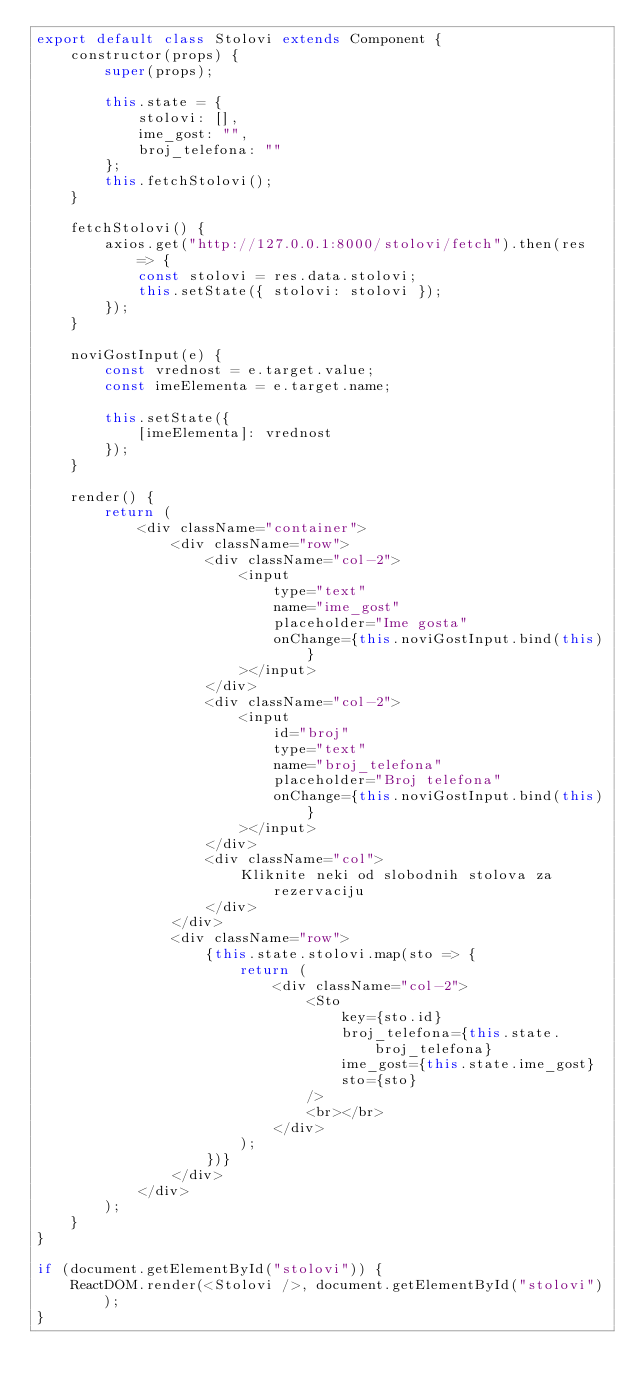Convert code to text. <code><loc_0><loc_0><loc_500><loc_500><_JavaScript_>export default class Stolovi extends Component {
    constructor(props) {
        super(props);

        this.state = {
            stolovi: [],
            ime_gost: "",
            broj_telefona: ""
        };
        this.fetchStolovi();
    }

    fetchStolovi() {
        axios.get("http://127.0.0.1:8000/stolovi/fetch").then(res => {
            const stolovi = res.data.stolovi;
            this.setState({ stolovi: stolovi });
        });
    }

    noviGostInput(e) {
        const vrednost = e.target.value;
        const imeElementa = e.target.name;

        this.setState({
            [imeElementa]: vrednost
        });
    }

    render() {
        return (
            <div className="container">
                <div className="row">
                    <div className="col-2">
                        <input
                            type="text"
                            name="ime_gost"
                            placeholder="Ime gosta"
                            onChange={this.noviGostInput.bind(this)}
                        ></input>
                    </div>
                    <div className="col-2">
                        <input
                            id="broj"
                            type="text"
                            name="broj_telefona"
                            placeholder="Broj telefona"
                            onChange={this.noviGostInput.bind(this)}
                        ></input>
                    </div>
                    <div className="col">
                        Kliknite neki od slobodnih stolova za rezervaciju
                    </div>
                </div>
                <div className="row">
                    {this.state.stolovi.map(sto => {
                        return (
                            <div className="col-2">
                                <Sto
                                    key={sto.id}
                                    broj_telefona={this.state.broj_telefona}
                                    ime_gost={this.state.ime_gost}
                                    sto={sto}
                                />
                                <br></br>
                            </div>
                        );
                    })}
                </div>
            </div>
        );
    }
}

if (document.getElementById("stolovi")) {
    ReactDOM.render(<Stolovi />, document.getElementById("stolovi"));
}
</code> 